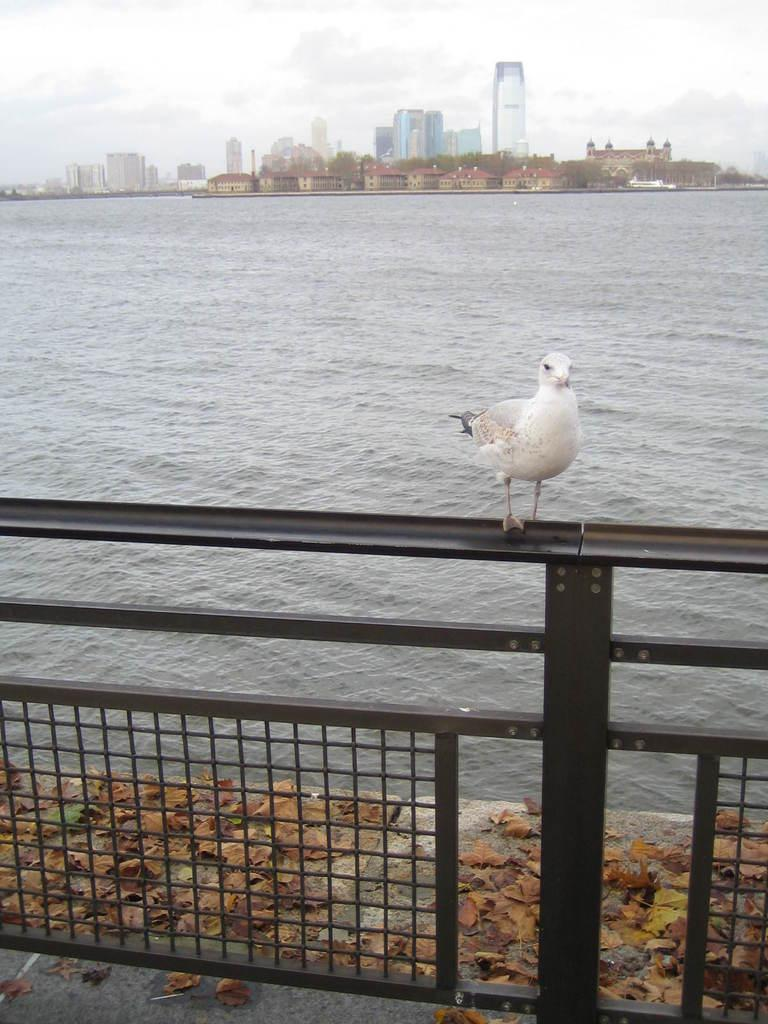What type of barrier can be seen in the image? There is a fence in the image. What type of vegetation is present in the image? Trees are present in the image. What natural element can be seen in the image? Dry leaves are present in the image. What can be seen in the sky in the image? The sky is visible in the image. What type of animal is present in the image? There is a bird in the image. What is the water feature in the image? Water is visible in the image. What type of flag is being held by the bird in the image? There is no flag present in the image, and the bird is not holding anything. How many balloons are tied to the tree in the image? There are no balloons present in the image. 